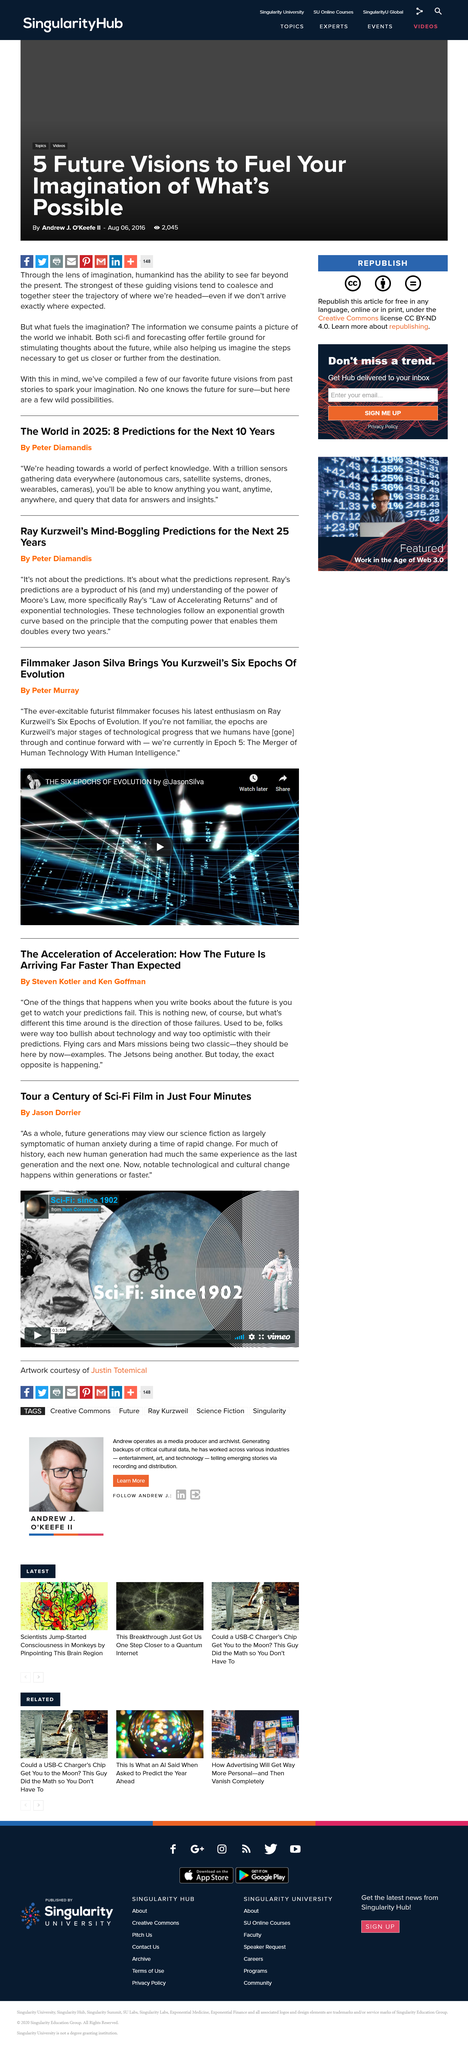Outline some significant characteristics in this image. This article is titled "The Acceleration of Acceleration: How The Future Is Arriving Far Faster Than Expected" and its name is "The Acceleration of Acceleration: How The Future Is Arriving Far Faster Than Expected". Writing books about the future allows you to witness your predictions being proven wrong. The book "The Acceleration of Acceleration: How The Future Is Arriving Far Faster Than Expected" was written by Steven Kotler and Ken Goffman. 